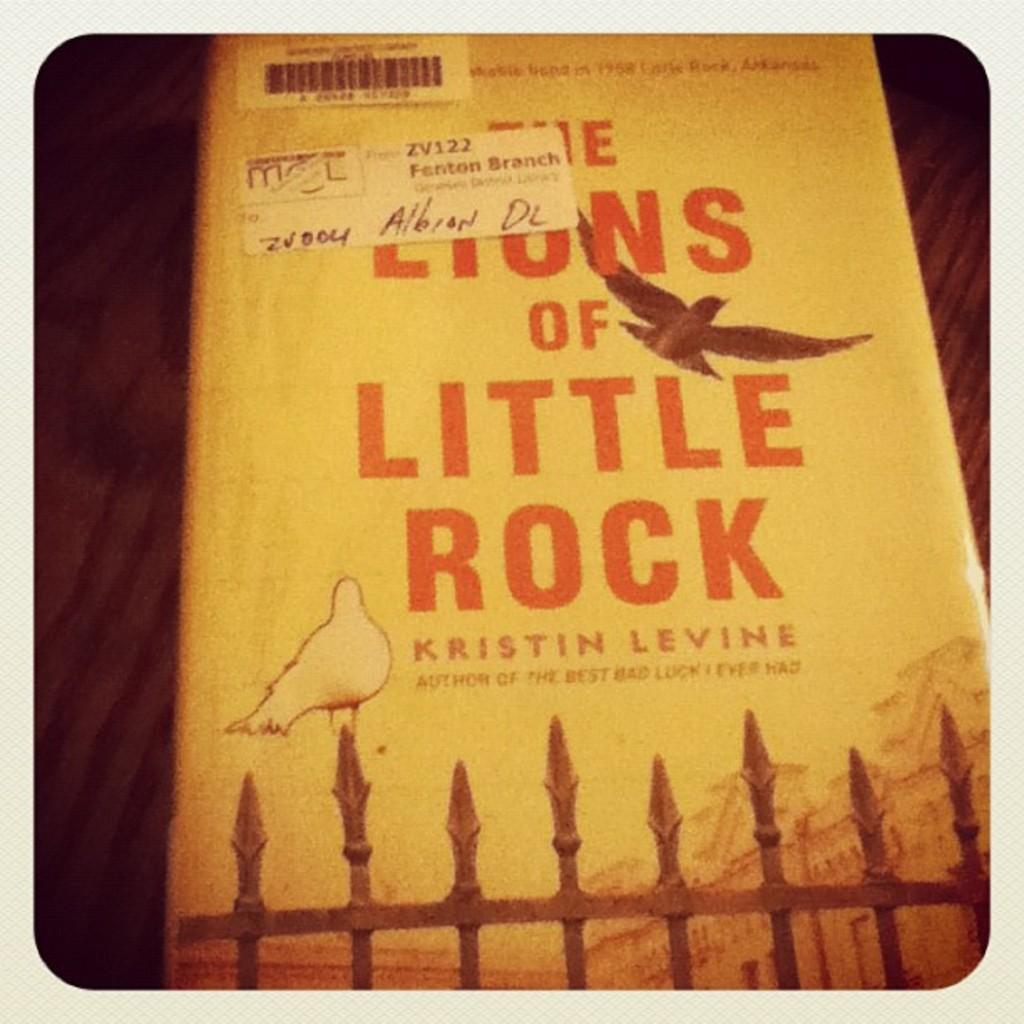<image>
Render a clear and concise summary of the photo. A book from the Fenton branch library has a bird on the cover. 